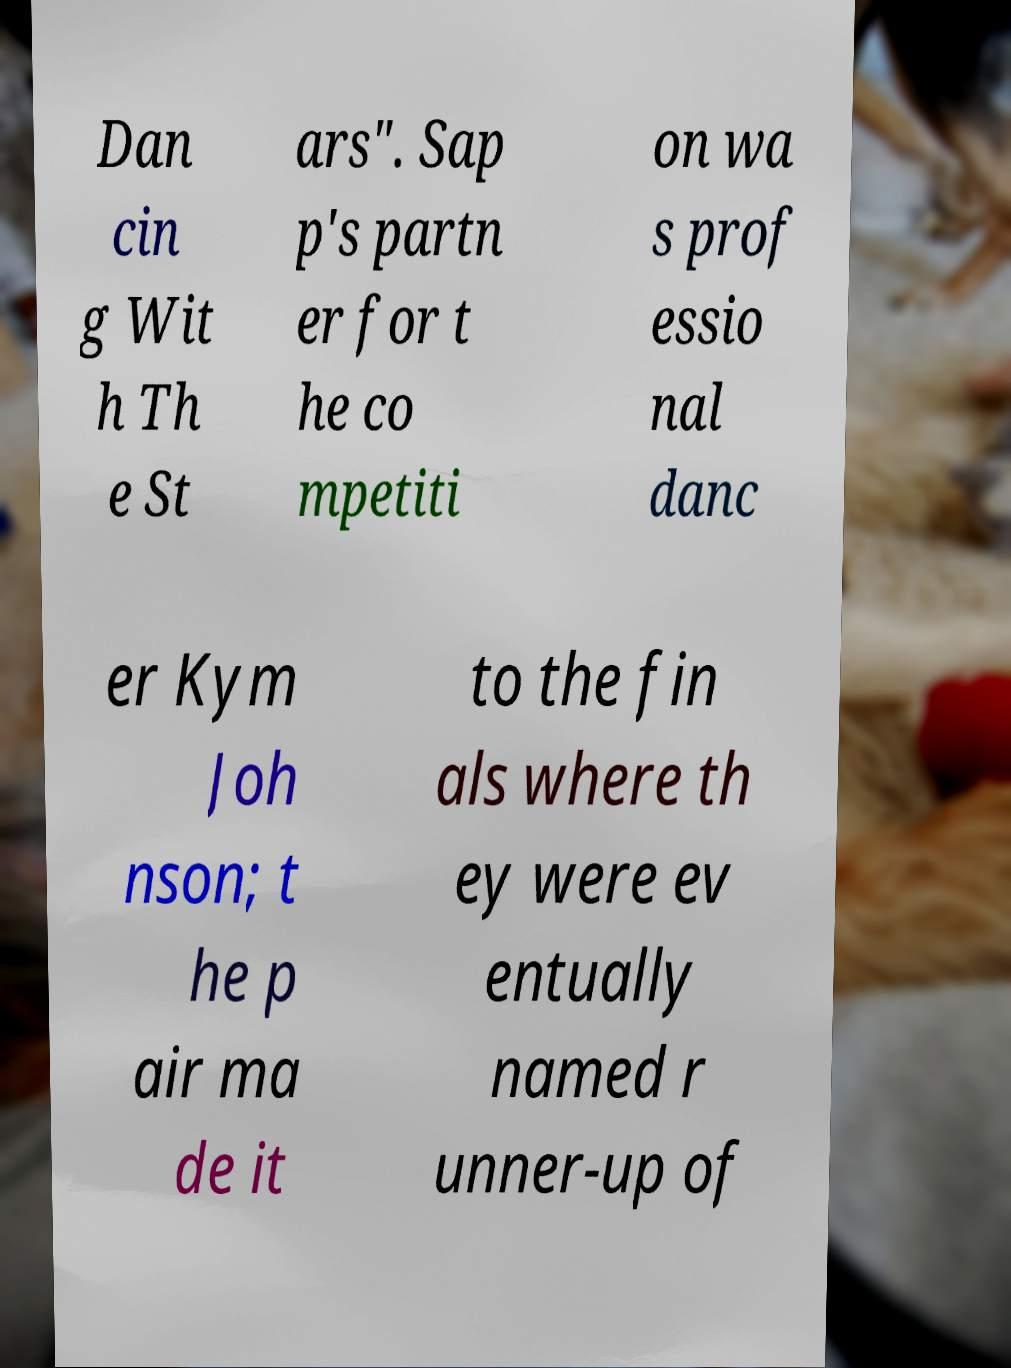There's text embedded in this image that I need extracted. Can you transcribe it verbatim? Dan cin g Wit h Th e St ars". Sap p's partn er for t he co mpetiti on wa s prof essio nal danc er Kym Joh nson; t he p air ma de it to the fin als where th ey were ev entually named r unner-up of 